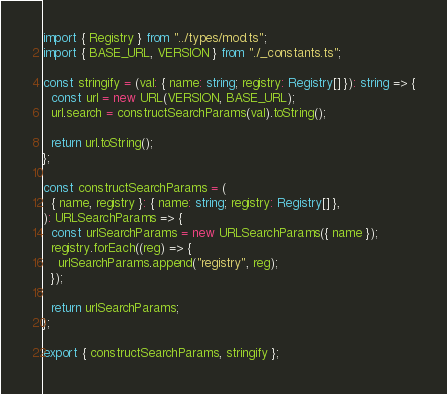Convert code to text. <code><loc_0><loc_0><loc_500><loc_500><_TypeScript_>import { Registry } from "../types/mod.ts";
import { BASE_URL, VERSION } from "./_constants.ts";

const stringify = (val: { name: string; registry: Registry[] }): string => {
  const url = new URL(VERSION, BASE_URL);
  url.search = constructSearchParams(val).toString();

  return url.toString();
};

const constructSearchParams = (
  { name, registry }: { name: string; registry: Registry[] },
): URLSearchParams => {
  const urlSearchParams = new URLSearchParams({ name });
  registry.forEach((reg) => {
    urlSearchParams.append("registry", reg);
  });

  return urlSearchParams;
};

export { constructSearchParams, stringify };
</code> 